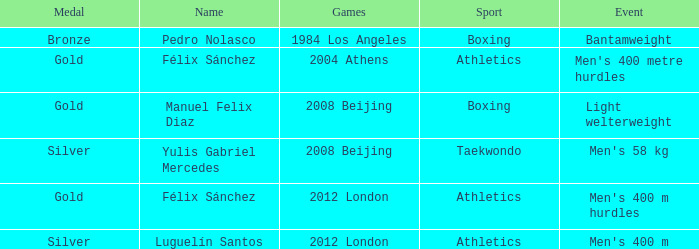In which sport was there an occurrence of men's 400 m hurdles? Athletics. 